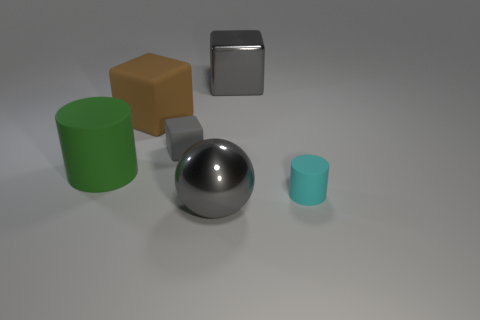Subtract all green cylinders. How many gray cubes are left? 2 Add 2 small gray blocks. How many objects exist? 8 Subtract all cylinders. How many objects are left? 4 Subtract all large blue metallic objects. Subtract all small gray matte objects. How many objects are left? 5 Add 6 large balls. How many large balls are left? 7 Add 3 purple objects. How many purple objects exist? 3 Subtract 0 blue blocks. How many objects are left? 6 